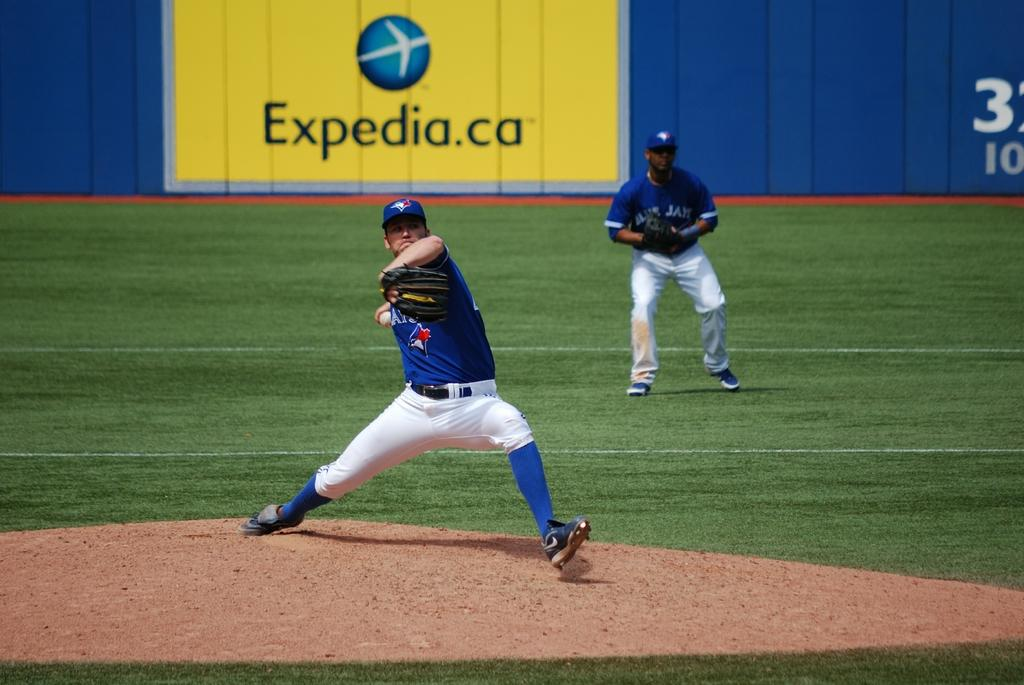<image>
Render a clear and concise summary of the photo. Baseball player pitching in front of a yellow ad which says Expedia. 